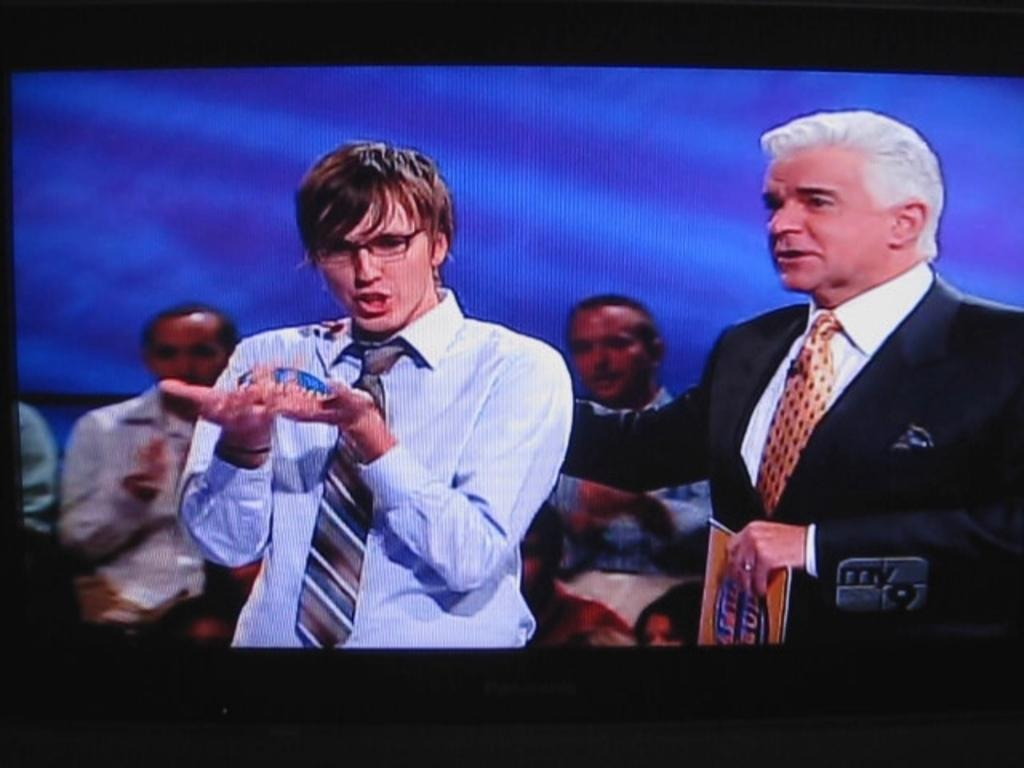<image>
Describe the image concisely. Men involved in a discussion, televised on channel 'my9'. 